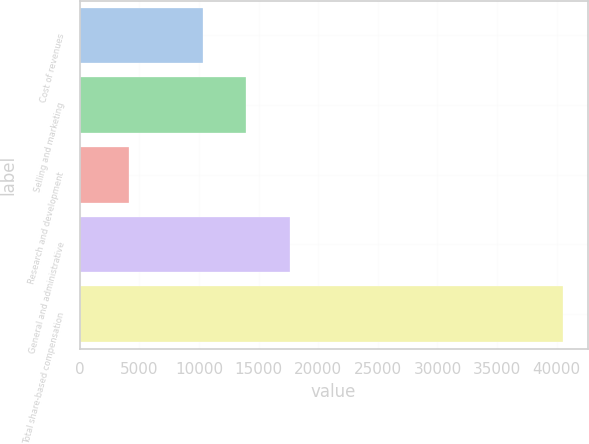<chart> <loc_0><loc_0><loc_500><loc_500><bar_chart><fcel>Cost of revenues<fcel>Selling and marketing<fcel>Research and development<fcel>General and administrative<fcel>Total share-based compensation<nl><fcel>10334<fcel>13972.8<fcel>4175<fcel>17611.6<fcel>40563<nl></chart> 